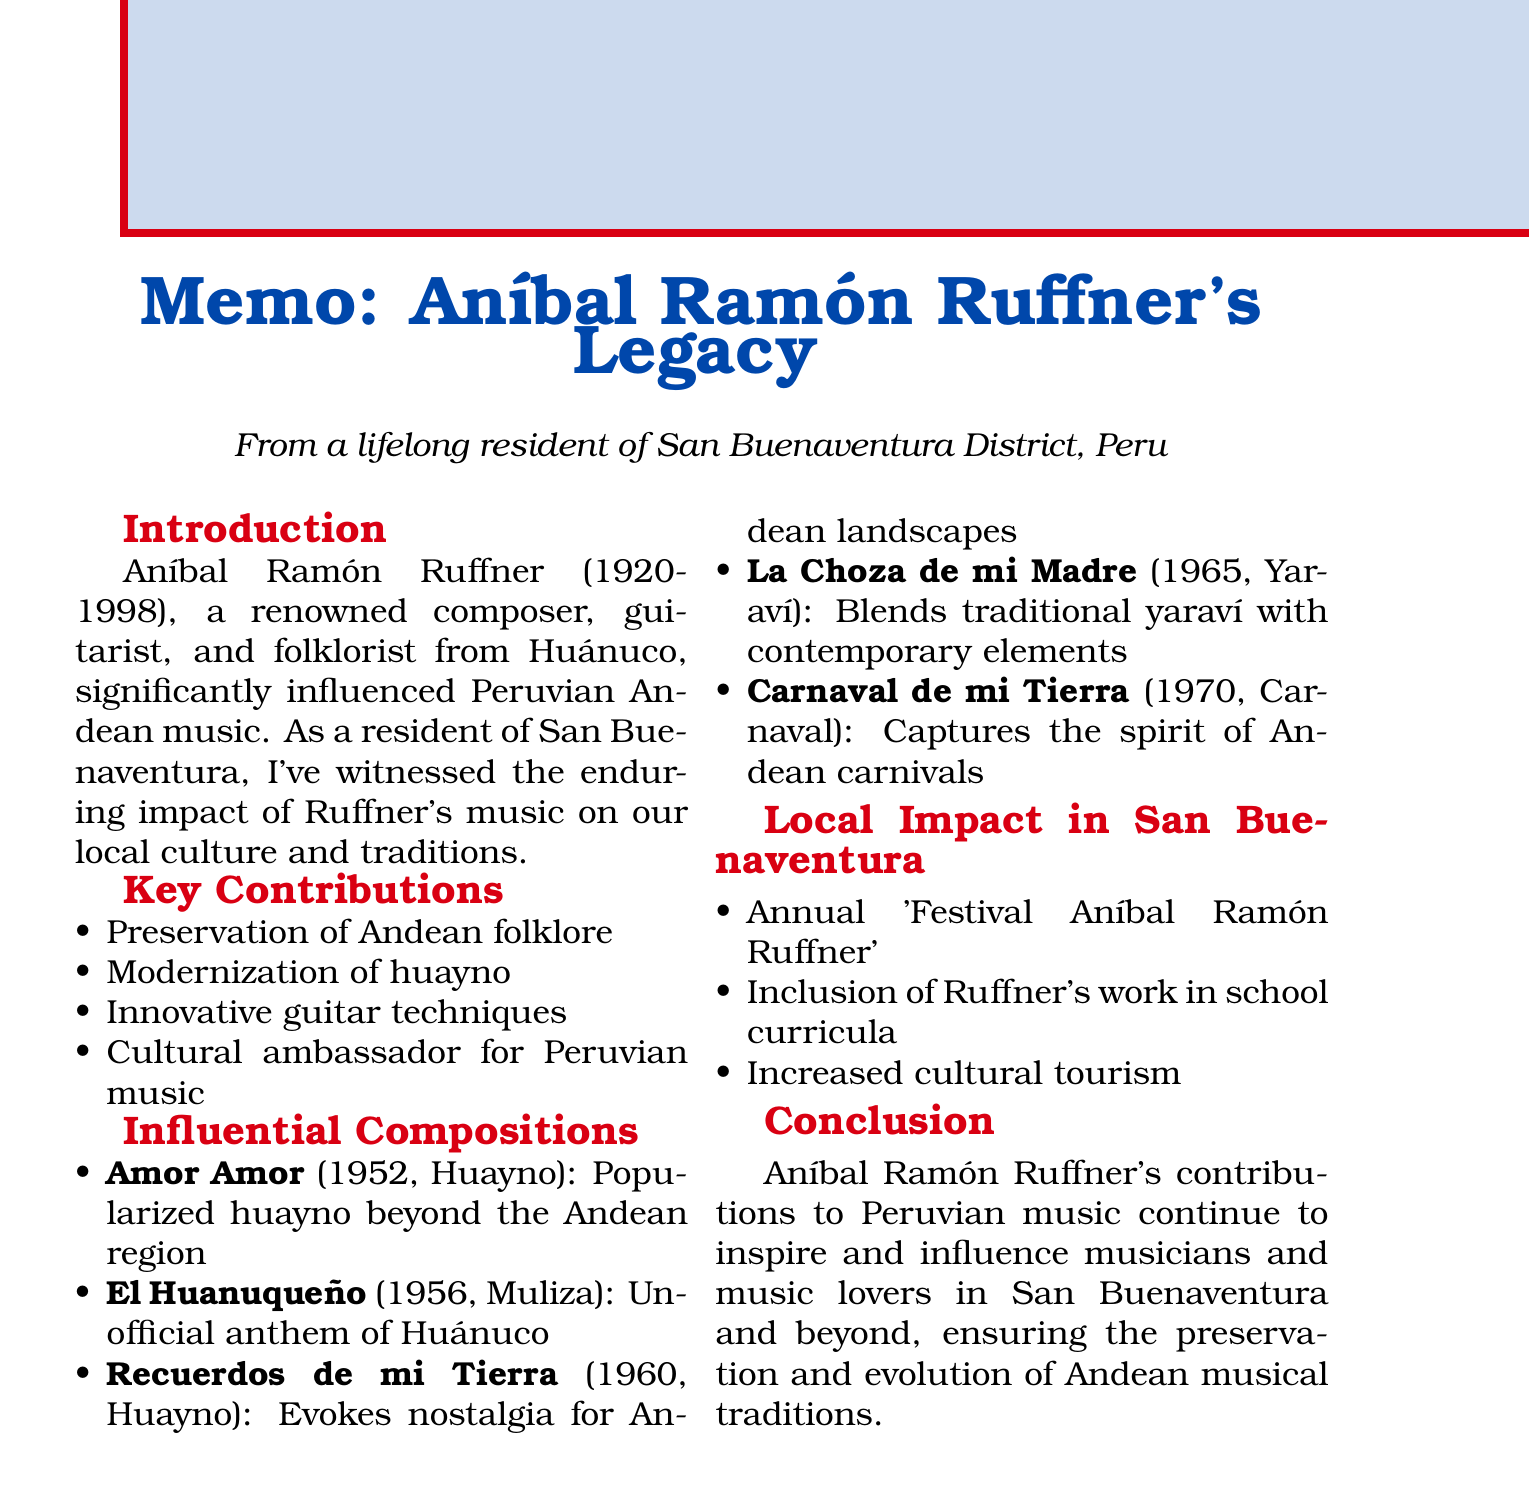What years did Aníbal Ramón Ruffner live? The document states that Aníbal Ramón Ruffner lived from 1920 to 1998.
Answer: 1920-1998 What is one of Ruffner's most famous compositions? The document mentions "Amor Amor" as one of Ruffner's most famous compositions.
Answer: Amor Amor In which city was Aníbal Ramón Ruffner born? The introduction states that he was from Huánuco, Peru.
Answer: Huánuco What festival is held annually in San Buenaventura District to celebrate Ruffner's legacy? The document refers to the "Festival Aníbal Ramón Ruffner."
Answer: Festival Aníbal Ramón Ruffner What genre is the composition "El Huanuqueño"? The document classifies "El Huanuqueño" as a Muliza.
Answer: Muliza How did Ruffner contribute to the modernization of huayno? He integrated contemporary musical elements into traditional huayno, according to the document.
Answer: Integrated contemporary musical elements What impact did Ruffner have on local cultural tourism? The document states that there was an increased cultural tourism due to interest in Ruffner's musical heritage.
Answer: Increased cultural tourism What type of music did Ruffner primarily focus on preserving? The document asserts that he focused on preserving Andean folklore.
Answer: Andean folklore When was the composition "Carnaval de mi Tierra" released? The document indicates that "Carnaval de mi Tierra" was released in 1970.
Answer: 1970 